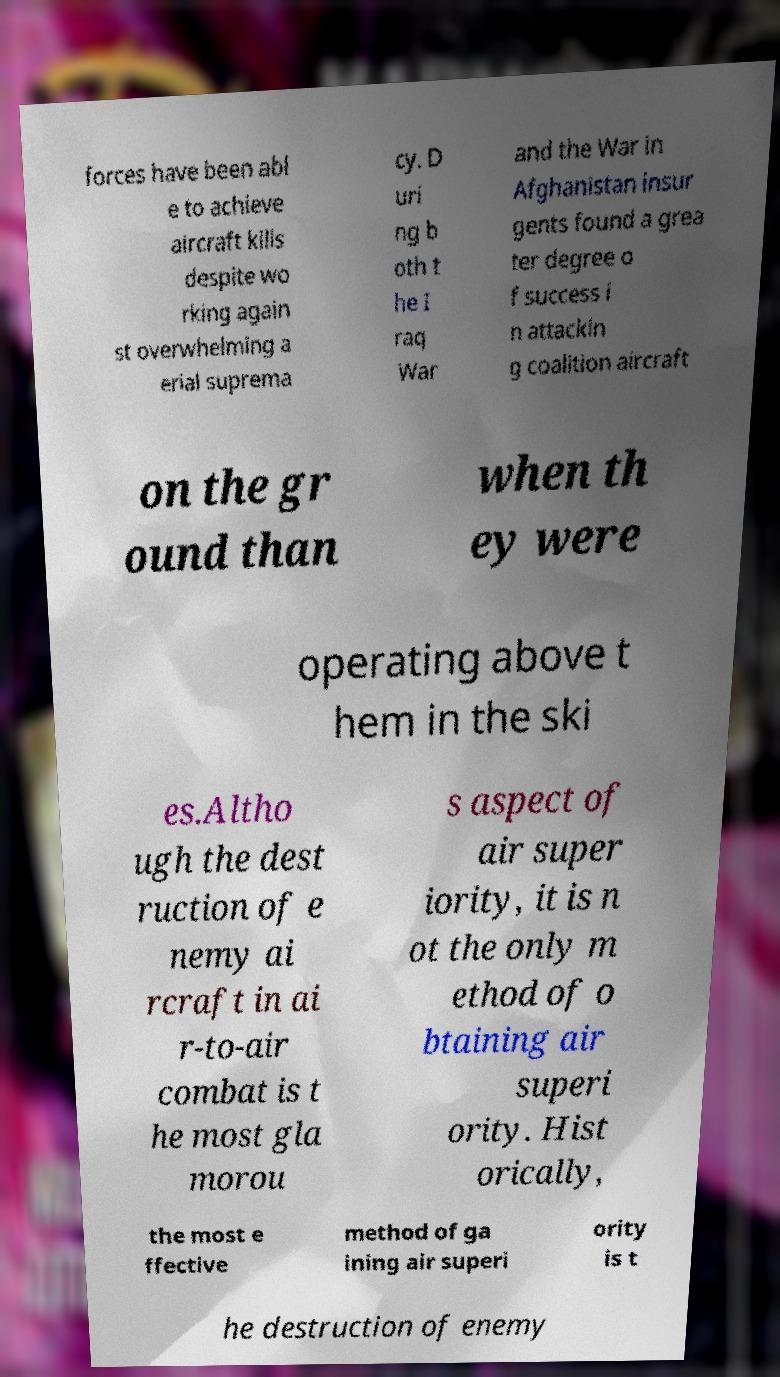What messages or text are displayed in this image? I need them in a readable, typed format. forces have been abl e to achieve aircraft kills despite wo rking again st overwhelming a erial suprema cy. D uri ng b oth t he I raq War and the War in Afghanistan insur gents found a grea ter degree o f success i n attackin g coalition aircraft on the gr ound than when th ey were operating above t hem in the ski es.Altho ugh the dest ruction of e nemy ai rcraft in ai r-to-air combat is t he most gla morou s aspect of air super iority, it is n ot the only m ethod of o btaining air superi ority. Hist orically, the most e ffective method of ga ining air superi ority is t he destruction of enemy 